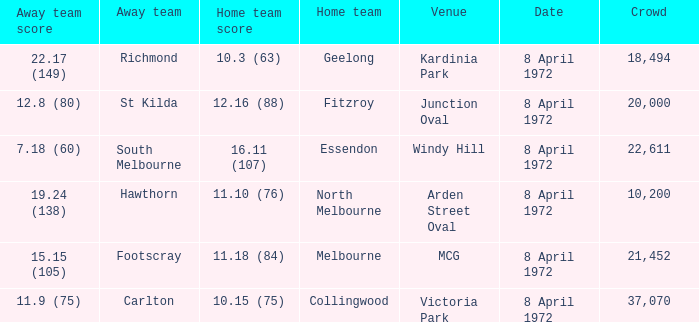Which Away team score has a Venue of kardinia park? 22.17 (149). 